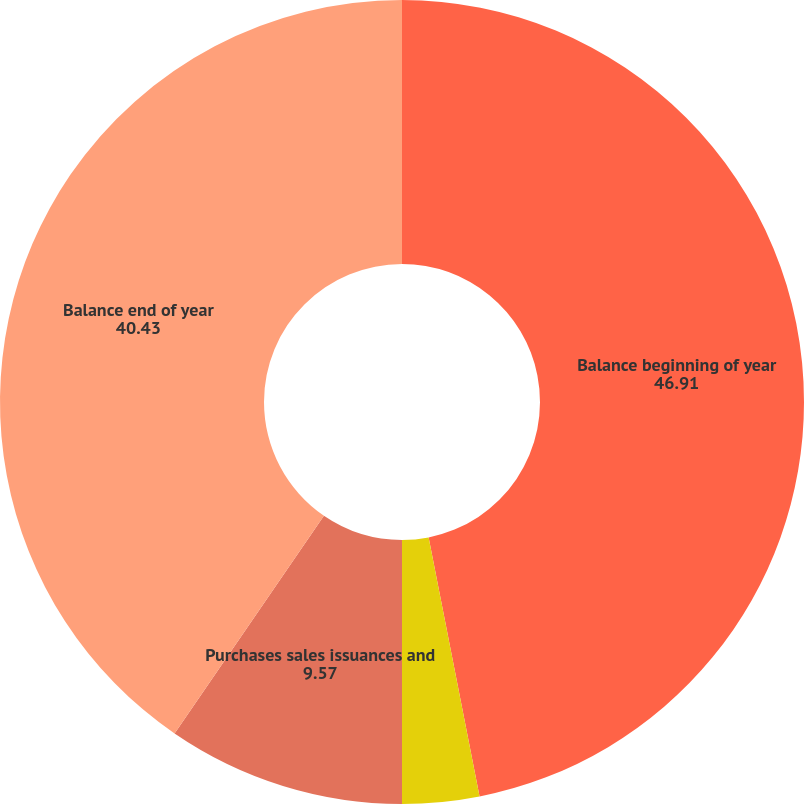Convert chart to OTSL. <chart><loc_0><loc_0><loc_500><loc_500><pie_chart><fcel>Balance beginning of year<fcel>Unrealized gains/(losses)<fcel>Purchases sales issuances and<fcel>Balance end of year<nl><fcel>46.91%<fcel>3.09%<fcel>9.57%<fcel>40.43%<nl></chart> 